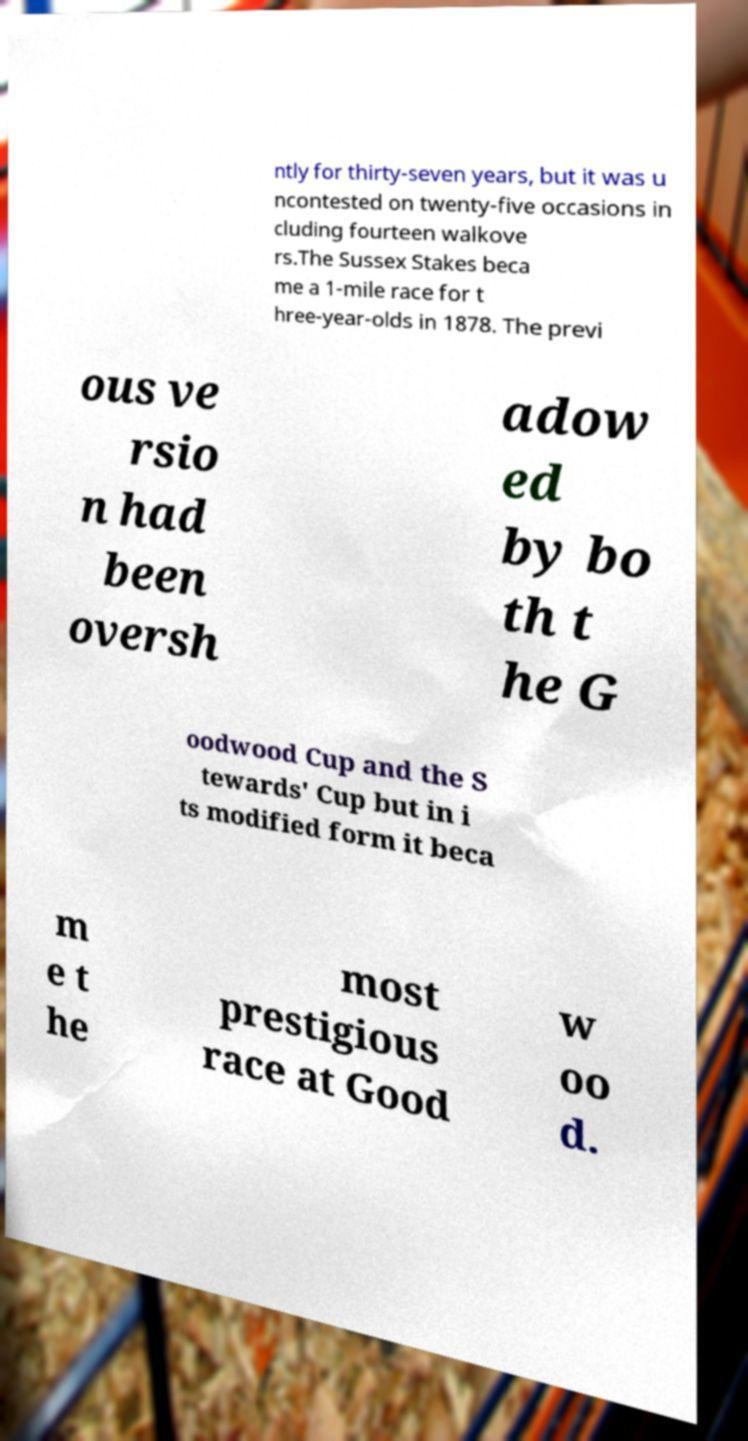I need the written content from this picture converted into text. Can you do that? ntly for thirty-seven years, but it was u ncontested on twenty-five occasions in cluding fourteen walkove rs.The Sussex Stakes beca me a 1-mile race for t hree-year-olds in 1878. The previ ous ve rsio n had been oversh adow ed by bo th t he G oodwood Cup and the S tewards' Cup but in i ts modified form it beca m e t he most prestigious race at Good w oo d. 